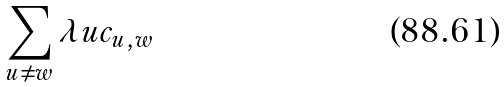<formula> <loc_0><loc_0><loc_500><loc_500>\sum _ { u \neq w } \lambda u c _ { u , w }</formula> 